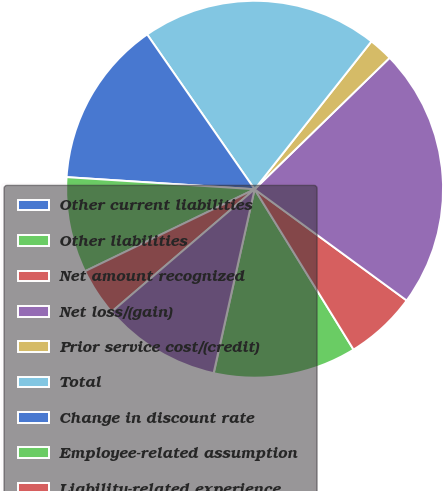<chart> <loc_0><loc_0><loc_500><loc_500><pie_chart><fcel>Other current liabilities<fcel>Other liabilities<fcel>Net amount recognized<fcel>Net loss/(gain)<fcel>Prior service cost/(credit)<fcel>Total<fcel>Change in discount rate<fcel>Employee-related assumption<fcel>Liability-related experience<fcel>Actual asset return different<nl><fcel>0.02%<fcel>12.27%<fcel>6.15%<fcel>22.34%<fcel>2.07%<fcel>20.3%<fcel>14.32%<fcel>8.19%<fcel>4.11%<fcel>10.23%<nl></chart> 